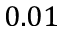<formula> <loc_0><loc_0><loc_500><loc_500>0 . 0 1</formula> 